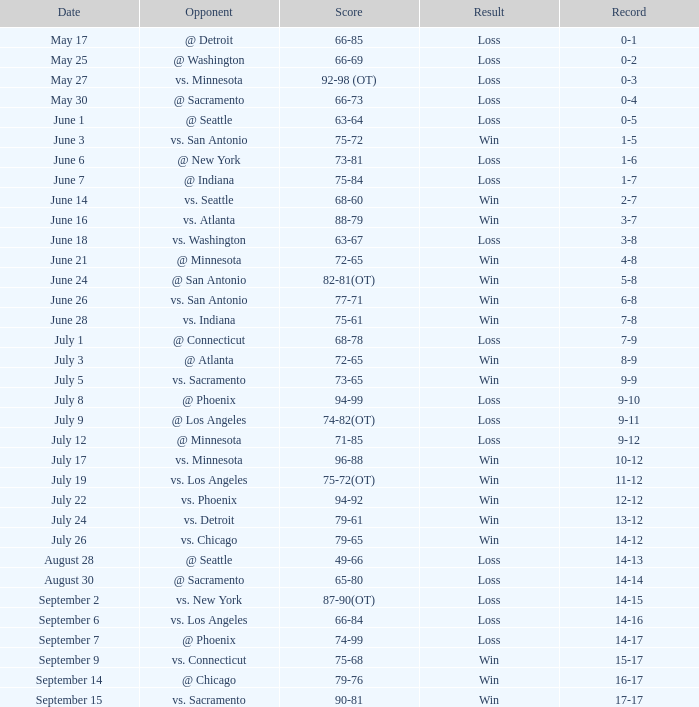Parse the table in full. {'header': ['Date', 'Opponent', 'Score', 'Result', 'Record'], 'rows': [['May 17', '@ Detroit', '66-85', 'Loss', '0-1'], ['May 25', '@ Washington', '66-69', 'Loss', '0-2'], ['May 27', 'vs. Minnesota', '92-98 (OT)', 'Loss', '0-3'], ['May 30', '@ Sacramento', '66-73', 'Loss', '0-4'], ['June 1', '@ Seattle', '63-64', 'Loss', '0-5'], ['June 3', 'vs. San Antonio', '75-72', 'Win', '1-5'], ['June 6', '@ New York', '73-81', 'Loss', '1-6'], ['June 7', '@ Indiana', '75-84', 'Loss', '1-7'], ['June 14', 'vs. Seattle', '68-60', 'Win', '2-7'], ['June 16', 'vs. Atlanta', '88-79', 'Win', '3-7'], ['June 18', 'vs. Washington', '63-67', 'Loss', '3-8'], ['June 21', '@ Minnesota', '72-65', 'Win', '4-8'], ['June 24', '@ San Antonio', '82-81(OT)', 'Win', '5-8'], ['June 26', 'vs. San Antonio', '77-71', 'Win', '6-8'], ['June 28', 'vs. Indiana', '75-61', 'Win', '7-8'], ['July 1', '@ Connecticut', '68-78', 'Loss', '7-9'], ['July 3', '@ Atlanta', '72-65', 'Win', '8-9'], ['July 5', 'vs. Sacramento', '73-65', 'Win', '9-9'], ['July 8', '@ Phoenix', '94-99', 'Loss', '9-10'], ['July 9', '@ Los Angeles', '74-82(OT)', 'Loss', '9-11'], ['July 12', '@ Minnesota', '71-85', 'Loss', '9-12'], ['July 17', 'vs. Minnesota', '96-88', 'Win', '10-12'], ['July 19', 'vs. Los Angeles', '75-72(OT)', 'Win', '11-12'], ['July 22', 'vs. Phoenix', '94-92', 'Win', '12-12'], ['July 24', 'vs. Detroit', '79-61', 'Win', '13-12'], ['July 26', 'vs. Chicago', '79-65', 'Win', '14-12'], ['August 28', '@ Seattle', '49-66', 'Loss', '14-13'], ['August 30', '@ Sacramento', '65-80', 'Loss', '14-14'], ['September 2', 'vs. New York', '87-90(OT)', 'Loss', '14-15'], ['September 6', 'vs. Los Angeles', '66-84', 'Loss', '14-16'], ['September 7', '@ Phoenix', '74-99', 'Loss', '14-17'], ['September 9', 'vs. Connecticut', '75-68', 'Win', '15-17'], ['September 14', '@ Chicago', '79-76', 'Win', '16-17'], ['September 15', 'vs. Sacramento', '90-81', 'Win', '17-17']]} What was the Result on May 30? Loss. 